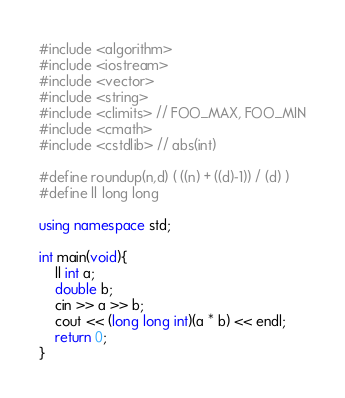Convert code to text. <code><loc_0><loc_0><loc_500><loc_500><_C++_>#include <algorithm>
#include <iostream>
#include <vector>
#include <string>
#include <climits> // FOO_MAX, FOO_MIN
#include <cmath> 
#include <cstdlib> // abs(int)

#define roundup(n,d) ( ((n) + ((d)-1)) / (d) )
#define ll long long

using namespace std;

int main(void){
    ll int a;
    double b;
    cin >> a >> b;
    cout << (long long int)(a * b) << endl;
    return 0;
}</code> 